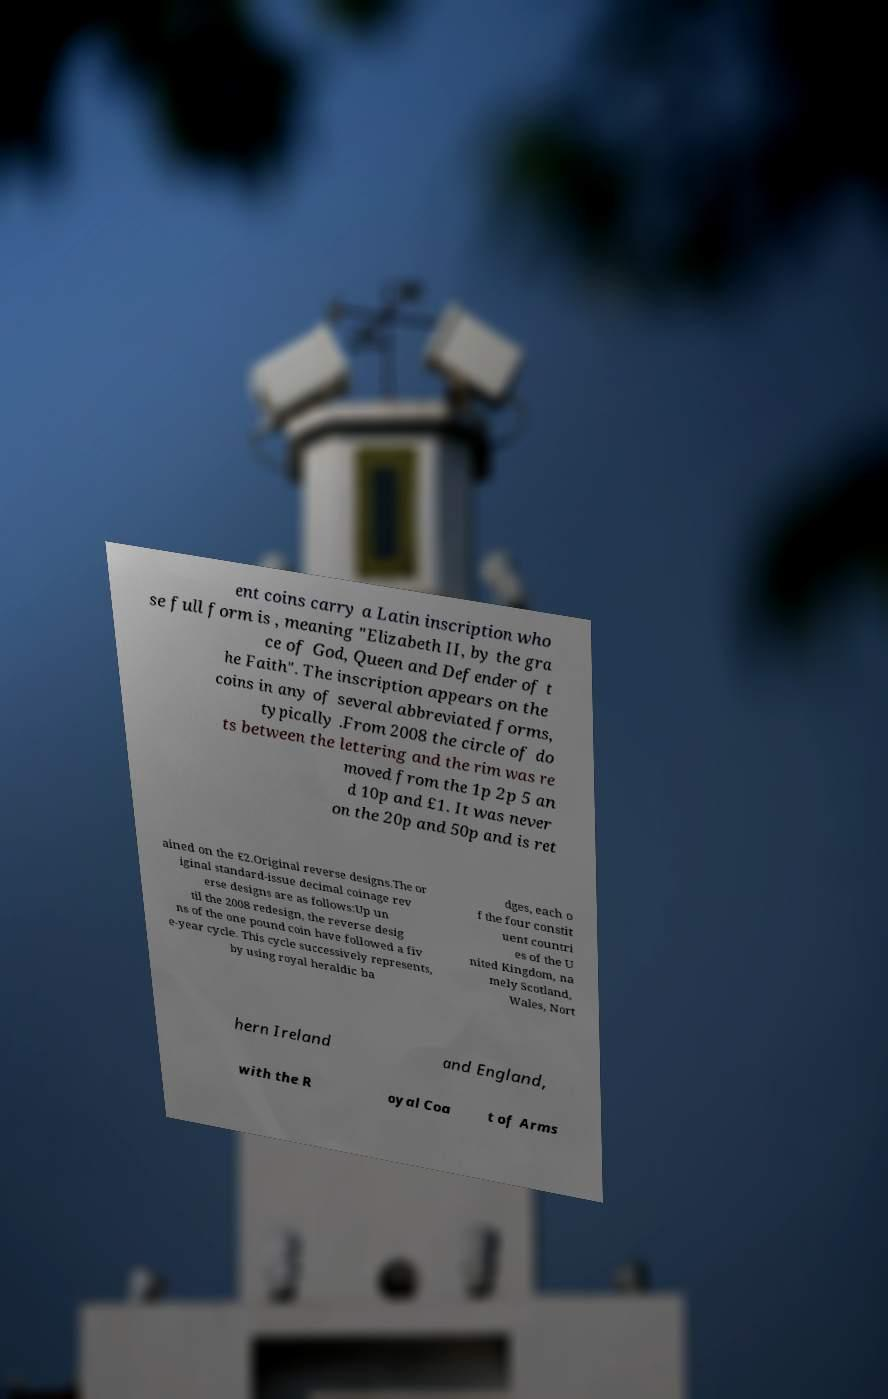I need the written content from this picture converted into text. Can you do that? ent coins carry a Latin inscription who se full form is , meaning "Elizabeth II, by the gra ce of God, Queen and Defender of t he Faith". The inscription appears on the coins in any of several abbreviated forms, typically .From 2008 the circle of do ts between the lettering and the rim was re moved from the 1p 2p 5 an d 10p and £1. It was never on the 20p and 50p and is ret ained on the £2.Original reverse designs.The or iginal standard-issue decimal coinage rev erse designs are as follows:Up un til the 2008 redesign, the reverse desig ns of the one pound coin have followed a fiv e-year cycle. This cycle successively represents, by using royal heraldic ba dges, each o f the four constit uent countri es of the U nited Kingdom, na mely Scotland, Wales, Nort hern Ireland and England, with the R oyal Coa t of Arms 